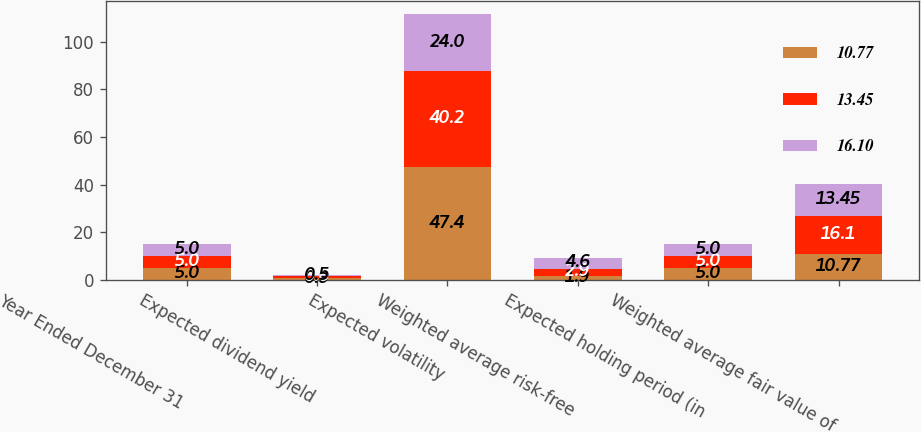Convert chart to OTSL. <chart><loc_0><loc_0><loc_500><loc_500><stacked_bar_chart><ecel><fcel>Year Ended December 31<fcel>Expected dividend yield<fcel>Expected volatility<fcel>Weighted average risk-free<fcel>Expected holding period (in<fcel>Weighted average fair value of<nl><fcel>10.77<fcel>5<fcel>0.9<fcel>47.4<fcel>1.9<fcel>5<fcel>10.77<nl><fcel>13.45<fcel>5<fcel>0.6<fcel>40.2<fcel>2.9<fcel>5<fcel>16.1<nl><fcel>16.1<fcel>5<fcel>0.5<fcel>24<fcel>4.6<fcel>5<fcel>13.45<nl></chart> 